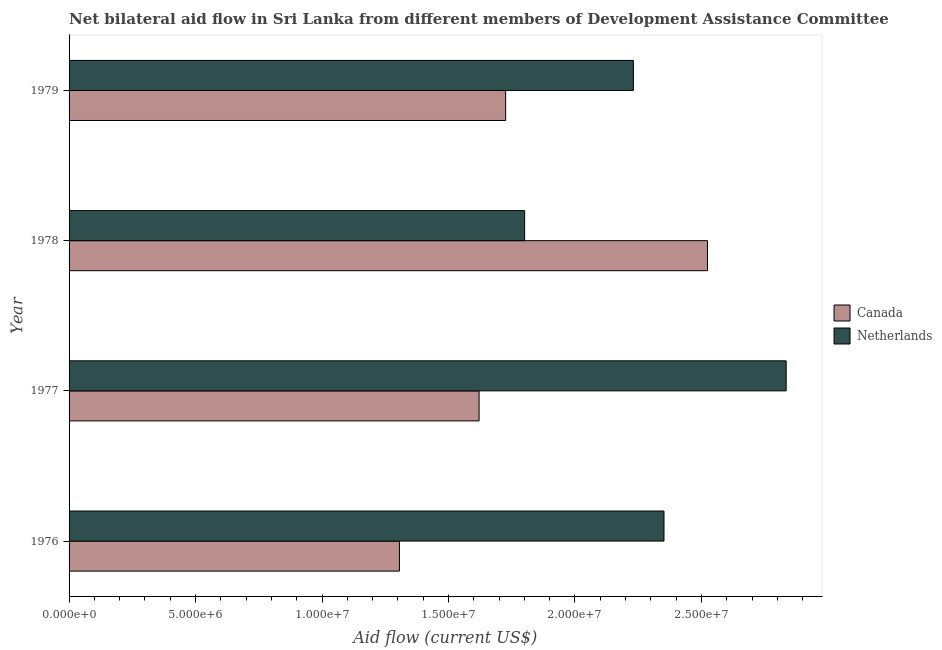Are the number of bars per tick equal to the number of legend labels?
Offer a very short reply. Yes. What is the label of the 4th group of bars from the top?
Offer a terse response. 1976. What is the amount of aid given by netherlands in 1977?
Ensure brevity in your answer.  2.84e+07. Across all years, what is the maximum amount of aid given by canada?
Your response must be concise. 2.52e+07. Across all years, what is the minimum amount of aid given by canada?
Keep it short and to the point. 1.31e+07. In which year was the amount of aid given by canada maximum?
Your answer should be compact. 1978. In which year was the amount of aid given by netherlands minimum?
Keep it short and to the point. 1978. What is the total amount of aid given by netherlands in the graph?
Offer a terse response. 9.22e+07. What is the difference between the amount of aid given by netherlands in 1976 and that in 1977?
Give a very brief answer. -4.83e+06. What is the difference between the amount of aid given by canada in 1976 and the amount of aid given by netherlands in 1979?
Provide a short and direct response. -9.25e+06. What is the average amount of aid given by netherlands per year?
Keep it short and to the point. 2.30e+07. In the year 1978, what is the difference between the amount of aid given by netherlands and amount of aid given by canada?
Your answer should be very brief. -7.23e+06. In how many years, is the amount of aid given by canada greater than 1000000 US$?
Provide a short and direct response. 4. What is the ratio of the amount of aid given by netherlands in 1978 to that in 1979?
Give a very brief answer. 0.81. What is the difference between the highest and the second highest amount of aid given by canada?
Offer a very short reply. 7.98e+06. What is the difference between the highest and the lowest amount of aid given by netherlands?
Offer a very short reply. 1.03e+07. In how many years, is the amount of aid given by netherlands greater than the average amount of aid given by netherlands taken over all years?
Your response must be concise. 2. What does the 2nd bar from the bottom in 1977 represents?
Your answer should be compact. Netherlands. How many years are there in the graph?
Offer a terse response. 4. Where does the legend appear in the graph?
Offer a terse response. Center right. How are the legend labels stacked?
Give a very brief answer. Vertical. What is the title of the graph?
Offer a very short reply. Net bilateral aid flow in Sri Lanka from different members of Development Assistance Committee. What is the label or title of the X-axis?
Make the answer very short. Aid flow (current US$). What is the label or title of the Y-axis?
Offer a very short reply. Year. What is the Aid flow (current US$) of Canada in 1976?
Provide a succinct answer. 1.31e+07. What is the Aid flow (current US$) in Netherlands in 1976?
Give a very brief answer. 2.35e+07. What is the Aid flow (current US$) in Canada in 1977?
Provide a short and direct response. 1.62e+07. What is the Aid flow (current US$) in Netherlands in 1977?
Make the answer very short. 2.84e+07. What is the Aid flow (current US$) in Canada in 1978?
Make the answer very short. 2.52e+07. What is the Aid flow (current US$) in Netherlands in 1978?
Make the answer very short. 1.80e+07. What is the Aid flow (current US$) of Canada in 1979?
Your answer should be very brief. 1.73e+07. What is the Aid flow (current US$) of Netherlands in 1979?
Your answer should be very brief. 2.23e+07. Across all years, what is the maximum Aid flow (current US$) of Canada?
Offer a terse response. 2.52e+07. Across all years, what is the maximum Aid flow (current US$) in Netherlands?
Your answer should be very brief. 2.84e+07. Across all years, what is the minimum Aid flow (current US$) of Canada?
Your response must be concise. 1.31e+07. Across all years, what is the minimum Aid flow (current US$) in Netherlands?
Keep it short and to the point. 1.80e+07. What is the total Aid flow (current US$) of Canada in the graph?
Offer a terse response. 7.18e+07. What is the total Aid flow (current US$) in Netherlands in the graph?
Provide a succinct answer. 9.22e+07. What is the difference between the Aid flow (current US$) of Canada in 1976 and that in 1977?
Make the answer very short. -3.15e+06. What is the difference between the Aid flow (current US$) in Netherlands in 1976 and that in 1977?
Your answer should be compact. -4.83e+06. What is the difference between the Aid flow (current US$) in Canada in 1976 and that in 1978?
Offer a very short reply. -1.22e+07. What is the difference between the Aid flow (current US$) of Netherlands in 1976 and that in 1978?
Your response must be concise. 5.51e+06. What is the difference between the Aid flow (current US$) of Canada in 1976 and that in 1979?
Your answer should be compact. -4.20e+06. What is the difference between the Aid flow (current US$) of Netherlands in 1976 and that in 1979?
Ensure brevity in your answer.  1.21e+06. What is the difference between the Aid flow (current US$) of Canada in 1977 and that in 1978?
Offer a very short reply. -9.03e+06. What is the difference between the Aid flow (current US$) of Netherlands in 1977 and that in 1978?
Your answer should be compact. 1.03e+07. What is the difference between the Aid flow (current US$) of Canada in 1977 and that in 1979?
Offer a terse response. -1.05e+06. What is the difference between the Aid flow (current US$) in Netherlands in 1977 and that in 1979?
Keep it short and to the point. 6.04e+06. What is the difference between the Aid flow (current US$) of Canada in 1978 and that in 1979?
Your response must be concise. 7.98e+06. What is the difference between the Aid flow (current US$) in Netherlands in 1978 and that in 1979?
Ensure brevity in your answer.  -4.30e+06. What is the difference between the Aid flow (current US$) in Canada in 1976 and the Aid flow (current US$) in Netherlands in 1977?
Offer a very short reply. -1.53e+07. What is the difference between the Aid flow (current US$) of Canada in 1976 and the Aid flow (current US$) of Netherlands in 1978?
Offer a very short reply. -4.95e+06. What is the difference between the Aid flow (current US$) in Canada in 1976 and the Aid flow (current US$) in Netherlands in 1979?
Make the answer very short. -9.25e+06. What is the difference between the Aid flow (current US$) in Canada in 1977 and the Aid flow (current US$) in Netherlands in 1978?
Keep it short and to the point. -1.80e+06. What is the difference between the Aid flow (current US$) of Canada in 1977 and the Aid flow (current US$) of Netherlands in 1979?
Give a very brief answer. -6.10e+06. What is the difference between the Aid flow (current US$) of Canada in 1978 and the Aid flow (current US$) of Netherlands in 1979?
Offer a terse response. 2.93e+06. What is the average Aid flow (current US$) of Canada per year?
Your answer should be very brief. 1.79e+07. What is the average Aid flow (current US$) of Netherlands per year?
Keep it short and to the point. 2.30e+07. In the year 1976, what is the difference between the Aid flow (current US$) of Canada and Aid flow (current US$) of Netherlands?
Ensure brevity in your answer.  -1.05e+07. In the year 1977, what is the difference between the Aid flow (current US$) in Canada and Aid flow (current US$) in Netherlands?
Keep it short and to the point. -1.21e+07. In the year 1978, what is the difference between the Aid flow (current US$) of Canada and Aid flow (current US$) of Netherlands?
Make the answer very short. 7.23e+06. In the year 1979, what is the difference between the Aid flow (current US$) in Canada and Aid flow (current US$) in Netherlands?
Your answer should be very brief. -5.05e+06. What is the ratio of the Aid flow (current US$) of Canada in 1976 to that in 1977?
Your answer should be very brief. 0.81. What is the ratio of the Aid flow (current US$) of Netherlands in 1976 to that in 1977?
Offer a very short reply. 0.83. What is the ratio of the Aid flow (current US$) in Canada in 1976 to that in 1978?
Ensure brevity in your answer.  0.52. What is the ratio of the Aid flow (current US$) of Netherlands in 1976 to that in 1978?
Ensure brevity in your answer.  1.31. What is the ratio of the Aid flow (current US$) in Canada in 1976 to that in 1979?
Your answer should be compact. 0.76. What is the ratio of the Aid flow (current US$) of Netherlands in 1976 to that in 1979?
Keep it short and to the point. 1.05. What is the ratio of the Aid flow (current US$) of Canada in 1977 to that in 1978?
Provide a succinct answer. 0.64. What is the ratio of the Aid flow (current US$) of Netherlands in 1977 to that in 1978?
Ensure brevity in your answer.  1.57. What is the ratio of the Aid flow (current US$) of Canada in 1977 to that in 1979?
Ensure brevity in your answer.  0.94. What is the ratio of the Aid flow (current US$) in Netherlands in 1977 to that in 1979?
Give a very brief answer. 1.27. What is the ratio of the Aid flow (current US$) in Canada in 1978 to that in 1979?
Ensure brevity in your answer.  1.46. What is the ratio of the Aid flow (current US$) in Netherlands in 1978 to that in 1979?
Your answer should be compact. 0.81. What is the difference between the highest and the second highest Aid flow (current US$) in Canada?
Keep it short and to the point. 7.98e+06. What is the difference between the highest and the second highest Aid flow (current US$) in Netherlands?
Ensure brevity in your answer.  4.83e+06. What is the difference between the highest and the lowest Aid flow (current US$) of Canada?
Provide a short and direct response. 1.22e+07. What is the difference between the highest and the lowest Aid flow (current US$) of Netherlands?
Your answer should be compact. 1.03e+07. 